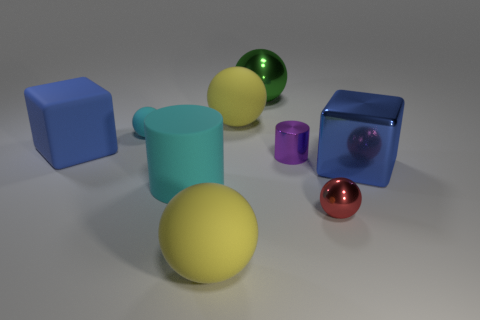Subtract 2 spheres. How many spheres are left? 3 Subtract all green spheres. How many spheres are left? 4 Subtract all green metallic balls. How many balls are left? 4 Subtract all blue spheres. Subtract all purple blocks. How many spheres are left? 5 Subtract all balls. How many objects are left? 4 Add 6 brown matte cylinders. How many brown matte cylinders exist? 6 Subtract 0 blue balls. How many objects are left? 9 Subtract all tiny cyan balls. Subtract all green metallic spheres. How many objects are left? 7 Add 1 large green shiny spheres. How many large green shiny spheres are left? 2 